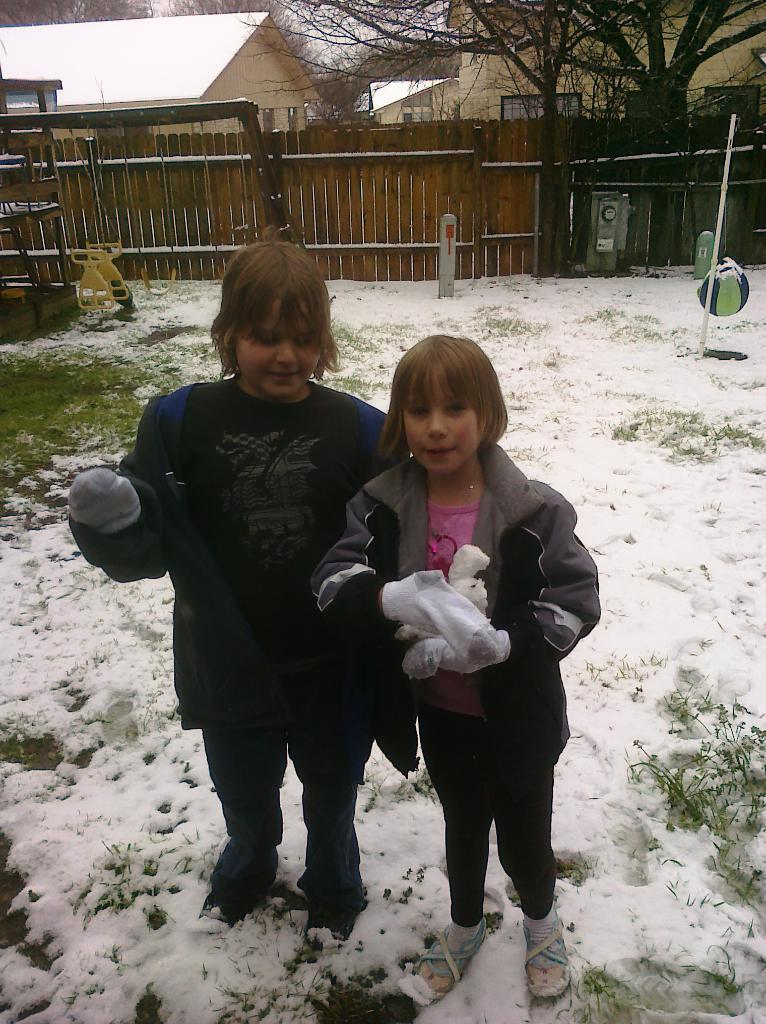How many kids are in the image? There are two kids in the image. What are the kids wearing? The kids are wearing jackets. What is the ground made of in the image? The kids are standing on snow. What can be seen in the background of the image? There is a wooden fence, trees, and houses in the background of the image. Who is wearing the crown in the image? There is no crown present in the image. What type of bomb can be seen in the image? There is no bomb present in the image. 